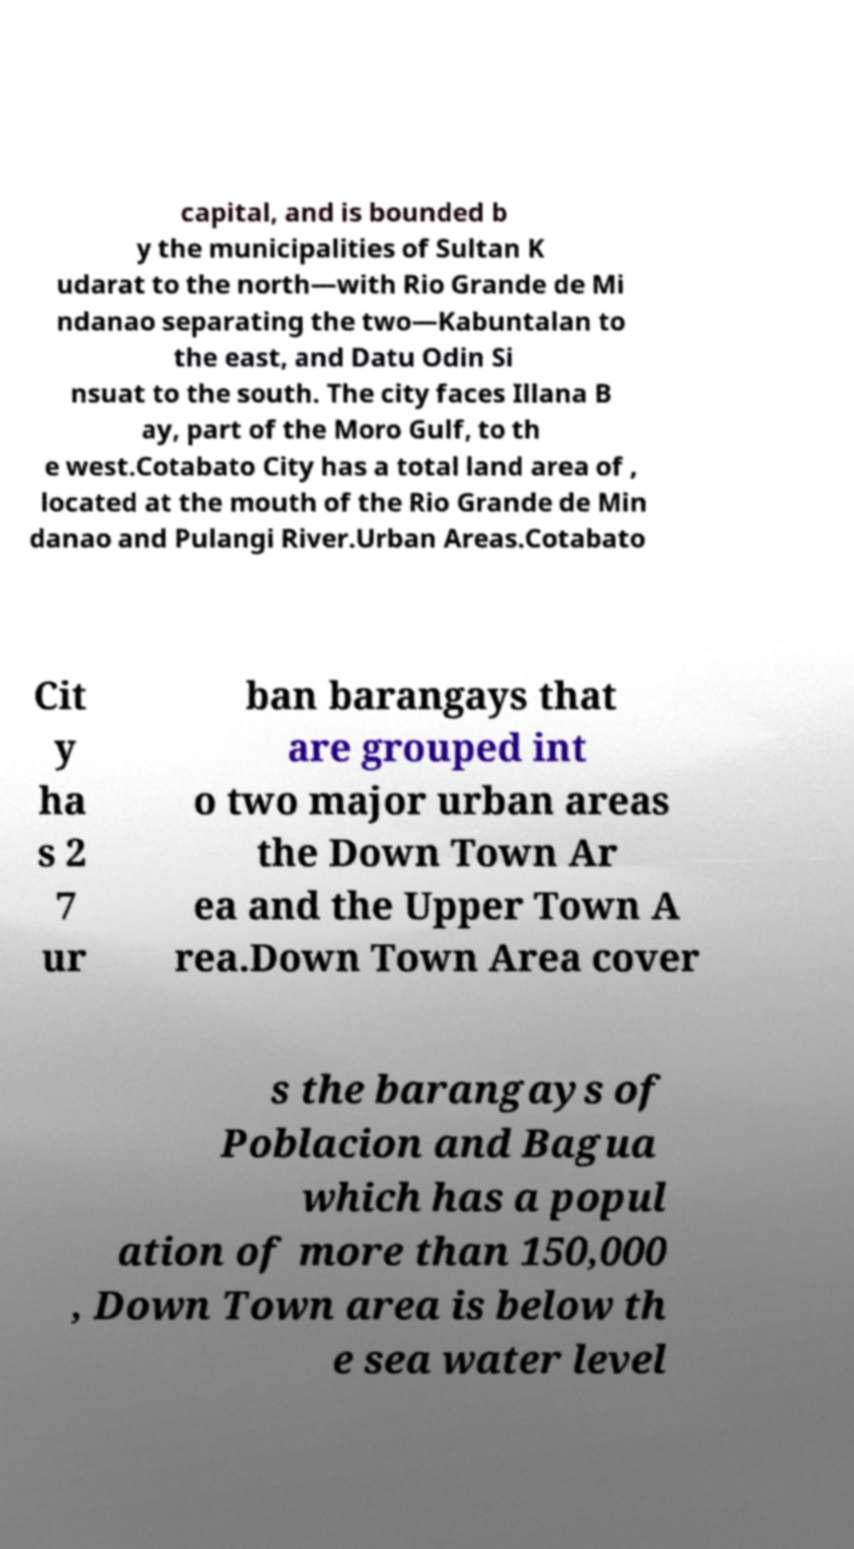Please identify and transcribe the text found in this image. capital, and is bounded b y the municipalities of Sultan K udarat to the north—with Rio Grande de Mi ndanao separating the two—Kabuntalan to the east, and Datu Odin Si nsuat to the south. The city faces Illana B ay, part of the Moro Gulf, to th e west.Cotabato City has a total land area of , located at the mouth of the Rio Grande de Min danao and Pulangi River.Urban Areas.Cotabato Cit y ha s 2 7 ur ban barangays that are grouped int o two major urban areas the Down Town Ar ea and the Upper Town A rea.Down Town Area cover s the barangays of Poblacion and Bagua which has a popul ation of more than 150,000 , Down Town area is below th e sea water level 